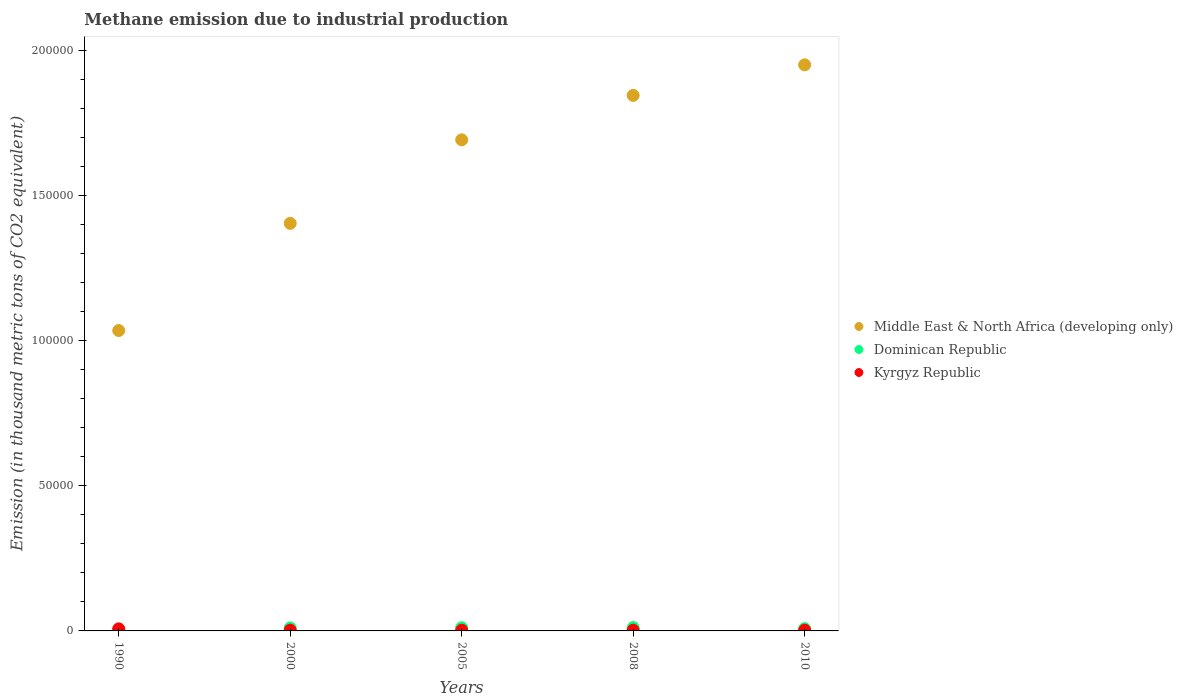What is the amount of methane emitted in Dominican Republic in 2010?
Your response must be concise. 781.7. Across all years, what is the maximum amount of methane emitted in Kyrgyz Republic?
Your answer should be compact. 709.3. Across all years, what is the minimum amount of methane emitted in Kyrgyz Republic?
Your answer should be compact. 242.8. In which year was the amount of methane emitted in Middle East & North Africa (developing only) maximum?
Make the answer very short. 2010. What is the total amount of methane emitted in Dominican Republic in the graph?
Provide a succinct answer. 4543.3. What is the difference between the amount of methane emitted in Middle East & North Africa (developing only) in 1990 and that in 2005?
Your response must be concise. -6.57e+04. What is the difference between the amount of methane emitted in Middle East & North Africa (developing only) in 2005 and the amount of methane emitted in Dominican Republic in 1990?
Give a very brief answer. 1.69e+05. What is the average amount of methane emitted in Kyrgyz Republic per year?
Your answer should be very brief. 346. In the year 2008, what is the difference between the amount of methane emitted in Kyrgyz Republic and amount of methane emitted in Dominican Republic?
Give a very brief answer. -897.5. What is the ratio of the amount of methane emitted in Kyrgyz Republic in 2000 to that in 2010?
Keep it short and to the point. 0.96. Is the amount of methane emitted in Dominican Republic in 2000 less than that in 2005?
Provide a succinct answer. Yes. Is the difference between the amount of methane emitted in Kyrgyz Republic in 2000 and 2005 greater than the difference between the amount of methane emitted in Dominican Republic in 2000 and 2005?
Offer a terse response. Yes. What is the difference between the highest and the second highest amount of methane emitted in Middle East & North Africa (developing only)?
Offer a terse response. 1.05e+04. What is the difference between the highest and the lowest amount of methane emitted in Kyrgyz Republic?
Provide a short and direct response. 466.5. In how many years, is the amount of methane emitted in Kyrgyz Republic greater than the average amount of methane emitted in Kyrgyz Republic taken over all years?
Offer a terse response. 1. Is the amount of methane emitted in Dominican Republic strictly greater than the amount of methane emitted in Middle East & North Africa (developing only) over the years?
Ensure brevity in your answer.  No. Is the amount of methane emitted in Kyrgyz Republic strictly less than the amount of methane emitted in Dominican Republic over the years?
Offer a terse response. No. What is the difference between two consecutive major ticks on the Y-axis?
Provide a succinct answer. 5.00e+04. Where does the legend appear in the graph?
Your answer should be compact. Center right. How are the legend labels stacked?
Your response must be concise. Vertical. What is the title of the graph?
Give a very brief answer. Methane emission due to industrial production. Does "Papua New Guinea" appear as one of the legend labels in the graph?
Keep it short and to the point. No. What is the label or title of the Y-axis?
Ensure brevity in your answer.  Emission (in thousand metric tons of CO2 equivalent). What is the Emission (in thousand metric tons of CO2 equivalent) of Middle East & North Africa (developing only) in 1990?
Keep it short and to the point. 1.03e+05. What is the Emission (in thousand metric tons of CO2 equivalent) of Dominican Republic in 1990?
Offer a terse response. 492.1. What is the Emission (in thousand metric tons of CO2 equivalent) of Kyrgyz Republic in 1990?
Your response must be concise. 709.3. What is the Emission (in thousand metric tons of CO2 equivalent) of Middle East & North Africa (developing only) in 2000?
Your response must be concise. 1.40e+05. What is the Emission (in thousand metric tons of CO2 equivalent) in Dominican Republic in 2000?
Your answer should be compact. 1030.4. What is the Emission (in thousand metric tons of CO2 equivalent) of Kyrgyz Republic in 2000?
Offer a terse response. 255.9. What is the Emission (in thousand metric tons of CO2 equivalent) in Middle East & North Africa (developing only) in 2005?
Make the answer very short. 1.69e+05. What is the Emission (in thousand metric tons of CO2 equivalent) of Dominican Republic in 2005?
Your answer should be compact. 1085.6. What is the Emission (in thousand metric tons of CO2 equivalent) in Kyrgyz Republic in 2005?
Provide a short and direct response. 242.8. What is the Emission (in thousand metric tons of CO2 equivalent) of Middle East & North Africa (developing only) in 2008?
Provide a short and direct response. 1.84e+05. What is the Emission (in thousand metric tons of CO2 equivalent) of Dominican Republic in 2008?
Give a very brief answer. 1153.5. What is the Emission (in thousand metric tons of CO2 equivalent) in Kyrgyz Republic in 2008?
Ensure brevity in your answer.  256. What is the Emission (in thousand metric tons of CO2 equivalent) in Middle East & North Africa (developing only) in 2010?
Offer a terse response. 1.95e+05. What is the Emission (in thousand metric tons of CO2 equivalent) of Dominican Republic in 2010?
Ensure brevity in your answer.  781.7. What is the Emission (in thousand metric tons of CO2 equivalent) of Kyrgyz Republic in 2010?
Your answer should be very brief. 266. Across all years, what is the maximum Emission (in thousand metric tons of CO2 equivalent) of Middle East & North Africa (developing only)?
Provide a short and direct response. 1.95e+05. Across all years, what is the maximum Emission (in thousand metric tons of CO2 equivalent) in Dominican Republic?
Provide a short and direct response. 1153.5. Across all years, what is the maximum Emission (in thousand metric tons of CO2 equivalent) of Kyrgyz Republic?
Make the answer very short. 709.3. Across all years, what is the minimum Emission (in thousand metric tons of CO2 equivalent) of Middle East & North Africa (developing only)?
Your answer should be compact. 1.03e+05. Across all years, what is the minimum Emission (in thousand metric tons of CO2 equivalent) of Dominican Republic?
Provide a short and direct response. 492.1. Across all years, what is the minimum Emission (in thousand metric tons of CO2 equivalent) of Kyrgyz Republic?
Make the answer very short. 242.8. What is the total Emission (in thousand metric tons of CO2 equivalent) in Middle East & North Africa (developing only) in the graph?
Provide a short and direct response. 7.92e+05. What is the total Emission (in thousand metric tons of CO2 equivalent) in Dominican Republic in the graph?
Your answer should be very brief. 4543.3. What is the total Emission (in thousand metric tons of CO2 equivalent) in Kyrgyz Republic in the graph?
Keep it short and to the point. 1730. What is the difference between the Emission (in thousand metric tons of CO2 equivalent) in Middle East & North Africa (developing only) in 1990 and that in 2000?
Offer a terse response. -3.69e+04. What is the difference between the Emission (in thousand metric tons of CO2 equivalent) in Dominican Republic in 1990 and that in 2000?
Make the answer very short. -538.3. What is the difference between the Emission (in thousand metric tons of CO2 equivalent) in Kyrgyz Republic in 1990 and that in 2000?
Give a very brief answer. 453.4. What is the difference between the Emission (in thousand metric tons of CO2 equivalent) of Middle East & North Africa (developing only) in 1990 and that in 2005?
Provide a short and direct response. -6.57e+04. What is the difference between the Emission (in thousand metric tons of CO2 equivalent) of Dominican Republic in 1990 and that in 2005?
Your answer should be compact. -593.5. What is the difference between the Emission (in thousand metric tons of CO2 equivalent) in Kyrgyz Republic in 1990 and that in 2005?
Your answer should be very brief. 466.5. What is the difference between the Emission (in thousand metric tons of CO2 equivalent) in Middle East & North Africa (developing only) in 1990 and that in 2008?
Give a very brief answer. -8.10e+04. What is the difference between the Emission (in thousand metric tons of CO2 equivalent) of Dominican Republic in 1990 and that in 2008?
Provide a short and direct response. -661.4. What is the difference between the Emission (in thousand metric tons of CO2 equivalent) in Kyrgyz Republic in 1990 and that in 2008?
Make the answer very short. 453.3. What is the difference between the Emission (in thousand metric tons of CO2 equivalent) of Middle East & North Africa (developing only) in 1990 and that in 2010?
Provide a short and direct response. -9.15e+04. What is the difference between the Emission (in thousand metric tons of CO2 equivalent) in Dominican Republic in 1990 and that in 2010?
Ensure brevity in your answer.  -289.6. What is the difference between the Emission (in thousand metric tons of CO2 equivalent) of Kyrgyz Republic in 1990 and that in 2010?
Your answer should be compact. 443.3. What is the difference between the Emission (in thousand metric tons of CO2 equivalent) of Middle East & North Africa (developing only) in 2000 and that in 2005?
Keep it short and to the point. -2.88e+04. What is the difference between the Emission (in thousand metric tons of CO2 equivalent) in Dominican Republic in 2000 and that in 2005?
Ensure brevity in your answer.  -55.2. What is the difference between the Emission (in thousand metric tons of CO2 equivalent) of Kyrgyz Republic in 2000 and that in 2005?
Ensure brevity in your answer.  13.1. What is the difference between the Emission (in thousand metric tons of CO2 equivalent) of Middle East & North Africa (developing only) in 2000 and that in 2008?
Provide a short and direct response. -4.41e+04. What is the difference between the Emission (in thousand metric tons of CO2 equivalent) of Dominican Republic in 2000 and that in 2008?
Ensure brevity in your answer.  -123.1. What is the difference between the Emission (in thousand metric tons of CO2 equivalent) of Middle East & North Africa (developing only) in 2000 and that in 2010?
Keep it short and to the point. -5.46e+04. What is the difference between the Emission (in thousand metric tons of CO2 equivalent) in Dominican Republic in 2000 and that in 2010?
Keep it short and to the point. 248.7. What is the difference between the Emission (in thousand metric tons of CO2 equivalent) of Middle East & North Africa (developing only) in 2005 and that in 2008?
Give a very brief answer. -1.53e+04. What is the difference between the Emission (in thousand metric tons of CO2 equivalent) in Dominican Republic in 2005 and that in 2008?
Keep it short and to the point. -67.9. What is the difference between the Emission (in thousand metric tons of CO2 equivalent) in Kyrgyz Republic in 2005 and that in 2008?
Offer a terse response. -13.2. What is the difference between the Emission (in thousand metric tons of CO2 equivalent) in Middle East & North Africa (developing only) in 2005 and that in 2010?
Offer a terse response. -2.58e+04. What is the difference between the Emission (in thousand metric tons of CO2 equivalent) in Dominican Republic in 2005 and that in 2010?
Offer a terse response. 303.9. What is the difference between the Emission (in thousand metric tons of CO2 equivalent) in Kyrgyz Republic in 2005 and that in 2010?
Your response must be concise. -23.2. What is the difference between the Emission (in thousand metric tons of CO2 equivalent) of Middle East & North Africa (developing only) in 2008 and that in 2010?
Provide a short and direct response. -1.05e+04. What is the difference between the Emission (in thousand metric tons of CO2 equivalent) in Dominican Republic in 2008 and that in 2010?
Keep it short and to the point. 371.8. What is the difference between the Emission (in thousand metric tons of CO2 equivalent) of Middle East & North Africa (developing only) in 1990 and the Emission (in thousand metric tons of CO2 equivalent) of Dominican Republic in 2000?
Ensure brevity in your answer.  1.02e+05. What is the difference between the Emission (in thousand metric tons of CO2 equivalent) of Middle East & North Africa (developing only) in 1990 and the Emission (in thousand metric tons of CO2 equivalent) of Kyrgyz Republic in 2000?
Provide a succinct answer. 1.03e+05. What is the difference between the Emission (in thousand metric tons of CO2 equivalent) of Dominican Republic in 1990 and the Emission (in thousand metric tons of CO2 equivalent) of Kyrgyz Republic in 2000?
Keep it short and to the point. 236.2. What is the difference between the Emission (in thousand metric tons of CO2 equivalent) in Middle East & North Africa (developing only) in 1990 and the Emission (in thousand metric tons of CO2 equivalent) in Dominican Republic in 2005?
Provide a short and direct response. 1.02e+05. What is the difference between the Emission (in thousand metric tons of CO2 equivalent) of Middle East & North Africa (developing only) in 1990 and the Emission (in thousand metric tons of CO2 equivalent) of Kyrgyz Republic in 2005?
Offer a very short reply. 1.03e+05. What is the difference between the Emission (in thousand metric tons of CO2 equivalent) of Dominican Republic in 1990 and the Emission (in thousand metric tons of CO2 equivalent) of Kyrgyz Republic in 2005?
Make the answer very short. 249.3. What is the difference between the Emission (in thousand metric tons of CO2 equivalent) of Middle East & North Africa (developing only) in 1990 and the Emission (in thousand metric tons of CO2 equivalent) of Dominican Republic in 2008?
Your answer should be compact. 1.02e+05. What is the difference between the Emission (in thousand metric tons of CO2 equivalent) of Middle East & North Africa (developing only) in 1990 and the Emission (in thousand metric tons of CO2 equivalent) of Kyrgyz Republic in 2008?
Offer a very short reply. 1.03e+05. What is the difference between the Emission (in thousand metric tons of CO2 equivalent) of Dominican Republic in 1990 and the Emission (in thousand metric tons of CO2 equivalent) of Kyrgyz Republic in 2008?
Provide a succinct answer. 236.1. What is the difference between the Emission (in thousand metric tons of CO2 equivalent) of Middle East & North Africa (developing only) in 1990 and the Emission (in thousand metric tons of CO2 equivalent) of Dominican Republic in 2010?
Your answer should be compact. 1.03e+05. What is the difference between the Emission (in thousand metric tons of CO2 equivalent) in Middle East & North Africa (developing only) in 1990 and the Emission (in thousand metric tons of CO2 equivalent) in Kyrgyz Republic in 2010?
Offer a terse response. 1.03e+05. What is the difference between the Emission (in thousand metric tons of CO2 equivalent) of Dominican Republic in 1990 and the Emission (in thousand metric tons of CO2 equivalent) of Kyrgyz Republic in 2010?
Ensure brevity in your answer.  226.1. What is the difference between the Emission (in thousand metric tons of CO2 equivalent) of Middle East & North Africa (developing only) in 2000 and the Emission (in thousand metric tons of CO2 equivalent) of Dominican Republic in 2005?
Offer a terse response. 1.39e+05. What is the difference between the Emission (in thousand metric tons of CO2 equivalent) in Middle East & North Africa (developing only) in 2000 and the Emission (in thousand metric tons of CO2 equivalent) in Kyrgyz Republic in 2005?
Make the answer very short. 1.40e+05. What is the difference between the Emission (in thousand metric tons of CO2 equivalent) in Dominican Republic in 2000 and the Emission (in thousand metric tons of CO2 equivalent) in Kyrgyz Republic in 2005?
Your answer should be compact. 787.6. What is the difference between the Emission (in thousand metric tons of CO2 equivalent) of Middle East & North Africa (developing only) in 2000 and the Emission (in thousand metric tons of CO2 equivalent) of Dominican Republic in 2008?
Offer a very short reply. 1.39e+05. What is the difference between the Emission (in thousand metric tons of CO2 equivalent) of Middle East & North Africa (developing only) in 2000 and the Emission (in thousand metric tons of CO2 equivalent) of Kyrgyz Republic in 2008?
Offer a terse response. 1.40e+05. What is the difference between the Emission (in thousand metric tons of CO2 equivalent) of Dominican Republic in 2000 and the Emission (in thousand metric tons of CO2 equivalent) of Kyrgyz Republic in 2008?
Ensure brevity in your answer.  774.4. What is the difference between the Emission (in thousand metric tons of CO2 equivalent) in Middle East & North Africa (developing only) in 2000 and the Emission (in thousand metric tons of CO2 equivalent) in Dominican Republic in 2010?
Make the answer very short. 1.40e+05. What is the difference between the Emission (in thousand metric tons of CO2 equivalent) in Middle East & North Africa (developing only) in 2000 and the Emission (in thousand metric tons of CO2 equivalent) in Kyrgyz Republic in 2010?
Provide a short and direct response. 1.40e+05. What is the difference between the Emission (in thousand metric tons of CO2 equivalent) in Dominican Republic in 2000 and the Emission (in thousand metric tons of CO2 equivalent) in Kyrgyz Republic in 2010?
Ensure brevity in your answer.  764.4. What is the difference between the Emission (in thousand metric tons of CO2 equivalent) in Middle East & North Africa (developing only) in 2005 and the Emission (in thousand metric tons of CO2 equivalent) in Dominican Republic in 2008?
Make the answer very short. 1.68e+05. What is the difference between the Emission (in thousand metric tons of CO2 equivalent) of Middle East & North Africa (developing only) in 2005 and the Emission (in thousand metric tons of CO2 equivalent) of Kyrgyz Republic in 2008?
Your response must be concise. 1.69e+05. What is the difference between the Emission (in thousand metric tons of CO2 equivalent) of Dominican Republic in 2005 and the Emission (in thousand metric tons of CO2 equivalent) of Kyrgyz Republic in 2008?
Offer a terse response. 829.6. What is the difference between the Emission (in thousand metric tons of CO2 equivalent) in Middle East & North Africa (developing only) in 2005 and the Emission (in thousand metric tons of CO2 equivalent) in Dominican Republic in 2010?
Make the answer very short. 1.68e+05. What is the difference between the Emission (in thousand metric tons of CO2 equivalent) in Middle East & North Africa (developing only) in 2005 and the Emission (in thousand metric tons of CO2 equivalent) in Kyrgyz Republic in 2010?
Give a very brief answer. 1.69e+05. What is the difference between the Emission (in thousand metric tons of CO2 equivalent) of Dominican Republic in 2005 and the Emission (in thousand metric tons of CO2 equivalent) of Kyrgyz Republic in 2010?
Provide a succinct answer. 819.6. What is the difference between the Emission (in thousand metric tons of CO2 equivalent) of Middle East & North Africa (developing only) in 2008 and the Emission (in thousand metric tons of CO2 equivalent) of Dominican Republic in 2010?
Provide a succinct answer. 1.84e+05. What is the difference between the Emission (in thousand metric tons of CO2 equivalent) in Middle East & North Africa (developing only) in 2008 and the Emission (in thousand metric tons of CO2 equivalent) in Kyrgyz Republic in 2010?
Your response must be concise. 1.84e+05. What is the difference between the Emission (in thousand metric tons of CO2 equivalent) in Dominican Republic in 2008 and the Emission (in thousand metric tons of CO2 equivalent) in Kyrgyz Republic in 2010?
Your response must be concise. 887.5. What is the average Emission (in thousand metric tons of CO2 equivalent) in Middle East & North Africa (developing only) per year?
Ensure brevity in your answer.  1.58e+05. What is the average Emission (in thousand metric tons of CO2 equivalent) in Dominican Republic per year?
Your response must be concise. 908.66. What is the average Emission (in thousand metric tons of CO2 equivalent) in Kyrgyz Republic per year?
Provide a short and direct response. 346. In the year 1990, what is the difference between the Emission (in thousand metric tons of CO2 equivalent) in Middle East & North Africa (developing only) and Emission (in thousand metric tons of CO2 equivalent) in Dominican Republic?
Offer a very short reply. 1.03e+05. In the year 1990, what is the difference between the Emission (in thousand metric tons of CO2 equivalent) of Middle East & North Africa (developing only) and Emission (in thousand metric tons of CO2 equivalent) of Kyrgyz Republic?
Make the answer very short. 1.03e+05. In the year 1990, what is the difference between the Emission (in thousand metric tons of CO2 equivalent) in Dominican Republic and Emission (in thousand metric tons of CO2 equivalent) in Kyrgyz Republic?
Keep it short and to the point. -217.2. In the year 2000, what is the difference between the Emission (in thousand metric tons of CO2 equivalent) in Middle East & North Africa (developing only) and Emission (in thousand metric tons of CO2 equivalent) in Dominican Republic?
Ensure brevity in your answer.  1.39e+05. In the year 2000, what is the difference between the Emission (in thousand metric tons of CO2 equivalent) in Middle East & North Africa (developing only) and Emission (in thousand metric tons of CO2 equivalent) in Kyrgyz Republic?
Your response must be concise. 1.40e+05. In the year 2000, what is the difference between the Emission (in thousand metric tons of CO2 equivalent) in Dominican Republic and Emission (in thousand metric tons of CO2 equivalent) in Kyrgyz Republic?
Keep it short and to the point. 774.5. In the year 2005, what is the difference between the Emission (in thousand metric tons of CO2 equivalent) of Middle East & North Africa (developing only) and Emission (in thousand metric tons of CO2 equivalent) of Dominican Republic?
Offer a very short reply. 1.68e+05. In the year 2005, what is the difference between the Emission (in thousand metric tons of CO2 equivalent) of Middle East & North Africa (developing only) and Emission (in thousand metric tons of CO2 equivalent) of Kyrgyz Republic?
Provide a short and direct response. 1.69e+05. In the year 2005, what is the difference between the Emission (in thousand metric tons of CO2 equivalent) of Dominican Republic and Emission (in thousand metric tons of CO2 equivalent) of Kyrgyz Republic?
Your response must be concise. 842.8. In the year 2008, what is the difference between the Emission (in thousand metric tons of CO2 equivalent) in Middle East & North Africa (developing only) and Emission (in thousand metric tons of CO2 equivalent) in Dominican Republic?
Make the answer very short. 1.83e+05. In the year 2008, what is the difference between the Emission (in thousand metric tons of CO2 equivalent) in Middle East & North Africa (developing only) and Emission (in thousand metric tons of CO2 equivalent) in Kyrgyz Republic?
Make the answer very short. 1.84e+05. In the year 2008, what is the difference between the Emission (in thousand metric tons of CO2 equivalent) of Dominican Republic and Emission (in thousand metric tons of CO2 equivalent) of Kyrgyz Republic?
Keep it short and to the point. 897.5. In the year 2010, what is the difference between the Emission (in thousand metric tons of CO2 equivalent) in Middle East & North Africa (developing only) and Emission (in thousand metric tons of CO2 equivalent) in Dominican Republic?
Provide a succinct answer. 1.94e+05. In the year 2010, what is the difference between the Emission (in thousand metric tons of CO2 equivalent) in Middle East & North Africa (developing only) and Emission (in thousand metric tons of CO2 equivalent) in Kyrgyz Republic?
Offer a very short reply. 1.95e+05. In the year 2010, what is the difference between the Emission (in thousand metric tons of CO2 equivalent) in Dominican Republic and Emission (in thousand metric tons of CO2 equivalent) in Kyrgyz Republic?
Offer a terse response. 515.7. What is the ratio of the Emission (in thousand metric tons of CO2 equivalent) of Middle East & North Africa (developing only) in 1990 to that in 2000?
Your response must be concise. 0.74. What is the ratio of the Emission (in thousand metric tons of CO2 equivalent) of Dominican Republic in 1990 to that in 2000?
Your answer should be compact. 0.48. What is the ratio of the Emission (in thousand metric tons of CO2 equivalent) of Kyrgyz Republic in 1990 to that in 2000?
Make the answer very short. 2.77. What is the ratio of the Emission (in thousand metric tons of CO2 equivalent) in Middle East & North Africa (developing only) in 1990 to that in 2005?
Offer a very short reply. 0.61. What is the ratio of the Emission (in thousand metric tons of CO2 equivalent) in Dominican Republic in 1990 to that in 2005?
Offer a very short reply. 0.45. What is the ratio of the Emission (in thousand metric tons of CO2 equivalent) of Kyrgyz Republic in 1990 to that in 2005?
Make the answer very short. 2.92. What is the ratio of the Emission (in thousand metric tons of CO2 equivalent) in Middle East & North Africa (developing only) in 1990 to that in 2008?
Provide a short and direct response. 0.56. What is the ratio of the Emission (in thousand metric tons of CO2 equivalent) of Dominican Republic in 1990 to that in 2008?
Make the answer very short. 0.43. What is the ratio of the Emission (in thousand metric tons of CO2 equivalent) of Kyrgyz Republic in 1990 to that in 2008?
Your answer should be compact. 2.77. What is the ratio of the Emission (in thousand metric tons of CO2 equivalent) in Middle East & North Africa (developing only) in 1990 to that in 2010?
Make the answer very short. 0.53. What is the ratio of the Emission (in thousand metric tons of CO2 equivalent) in Dominican Republic in 1990 to that in 2010?
Offer a very short reply. 0.63. What is the ratio of the Emission (in thousand metric tons of CO2 equivalent) in Kyrgyz Republic in 1990 to that in 2010?
Give a very brief answer. 2.67. What is the ratio of the Emission (in thousand metric tons of CO2 equivalent) of Middle East & North Africa (developing only) in 2000 to that in 2005?
Provide a short and direct response. 0.83. What is the ratio of the Emission (in thousand metric tons of CO2 equivalent) in Dominican Republic in 2000 to that in 2005?
Keep it short and to the point. 0.95. What is the ratio of the Emission (in thousand metric tons of CO2 equivalent) of Kyrgyz Republic in 2000 to that in 2005?
Your answer should be compact. 1.05. What is the ratio of the Emission (in thousand metric tons of CO2 equivalent) in Middle East & North Africa (developing only) in 2000 to that in 2008?
Your answer should be very brief. 0.76. What is the ratio of the Emission (in thousand metric tons of CO2 equivalent) in Dominican Republic in 2000 to that in 2008?
Give a very brief answer. 0.89. What is the ratio of the Emission (in thousand metric tons of CO2 equivalent) of Kyrgyz Republic in 2000 to that in 2008?
Give a very brief answer. 1. What is the ratio of the Emission (in thousand metric tons of CO2 equivalent) in Middle East & North Africa (developing only) in 2000 to that in 2010?
Provide a short and direct response. 0.72. What is the ratio of the Emission (in thousand metric tons of CO2 equivalent) of Dominican Republic in 2000 to that in 2010?
Give a very brief answer. 1.32. What is the ratio of the Emission (in thousand metric tons of CO2 equivalent) of Kyrgyz Republic in 2000 to that in 2010?
Keep it short and to the point. 0.96. What is the ratio of the Emission (in thousand metric tons of CO2 equivalent) in Middle East & North Africa (developing only) in 2005 to that in 2008?
Make the answer very short. 0.92. What is the ratio of the Emission (in thousand metric tons of CO2 equivalent) of Dominican Republic in 2005 to that in 2008?
Offer a very short reply. 0.94. What is the ratio of the Emission (in thousand metric tons of CO2 equivalent) in Kyrgyz Republic in 2005 to that in 2008?
Ensure brevity in your answer.  0.95. What is the ratio of the Emission (in thousand metric tons of CO2 equivalent) of Middle East & North Africa (developing only) in 2005 to that in 2010?
Provide a short and direct response. 0.87. What is the ratio of the Emission (in thousand metric tons of CO2 equivalent) in Dominican Republic in 2005 to that in 2010?
Provide a succinct answer. 1.39. What is the ratio of the Emission (in thousand metric tons of CO2 equivalent) in Kyrgyz Republic in 2005 to that in 2010?
Your answer should be compact. 0.91. What is the ratio of the Emission (in thousand metric tons of CO2 equivalent) of Middle East & North Africa (developing only) in 2008 to that in 2010?
Keep it short and to the point. 0.95. What is the ratio of the Emission (in thousand metric tons of CO2 equivalent) of Dominican Republic in 2008 to that in 2010?
Provide a short and direct response. 1.48. What is the ratio of the Emission (in thousand metric tons of CO2 equivalent) in Kyrgyz Republic in 2008 to that in 2010?
Your answer should be very brief. 0.96. What is the difference between the highest and the second highest Emission (in thousand metric tons of CO2 equivalent) in Middle East & North Africa (developing only)?
Offer a very short reply. 1.05e+04. What is the difference between the highest and the second highest Emission (in thousand metric tons of CO2 equivalent) of Dominican Republic?
Your answer should be compact. 67.9. What is the difference between the highest and the second highest Emission (in thousand metric tons of CO2 equivalent) in Kyrgyz Republic?
Provide a short and direct response. 443.3. What is the difference between the highest and the lowest Emission (in thousand metric tons of CO2 equivalent) in Middle East & North Africa (developing only)?
Offer a very short reply. 9.15e+04. What is the difference between the highest and the lowest Emission (in thousand metric tons of CO2 equivalent) in Dominican Republic?
Your answer should be very brief. 661.4. What is the difference between the highest and the lowest Emission (in thousand metric tons of CO2 equivalent) of Kyrgyz Republic?
Provide a short and direct response. 466.5. 